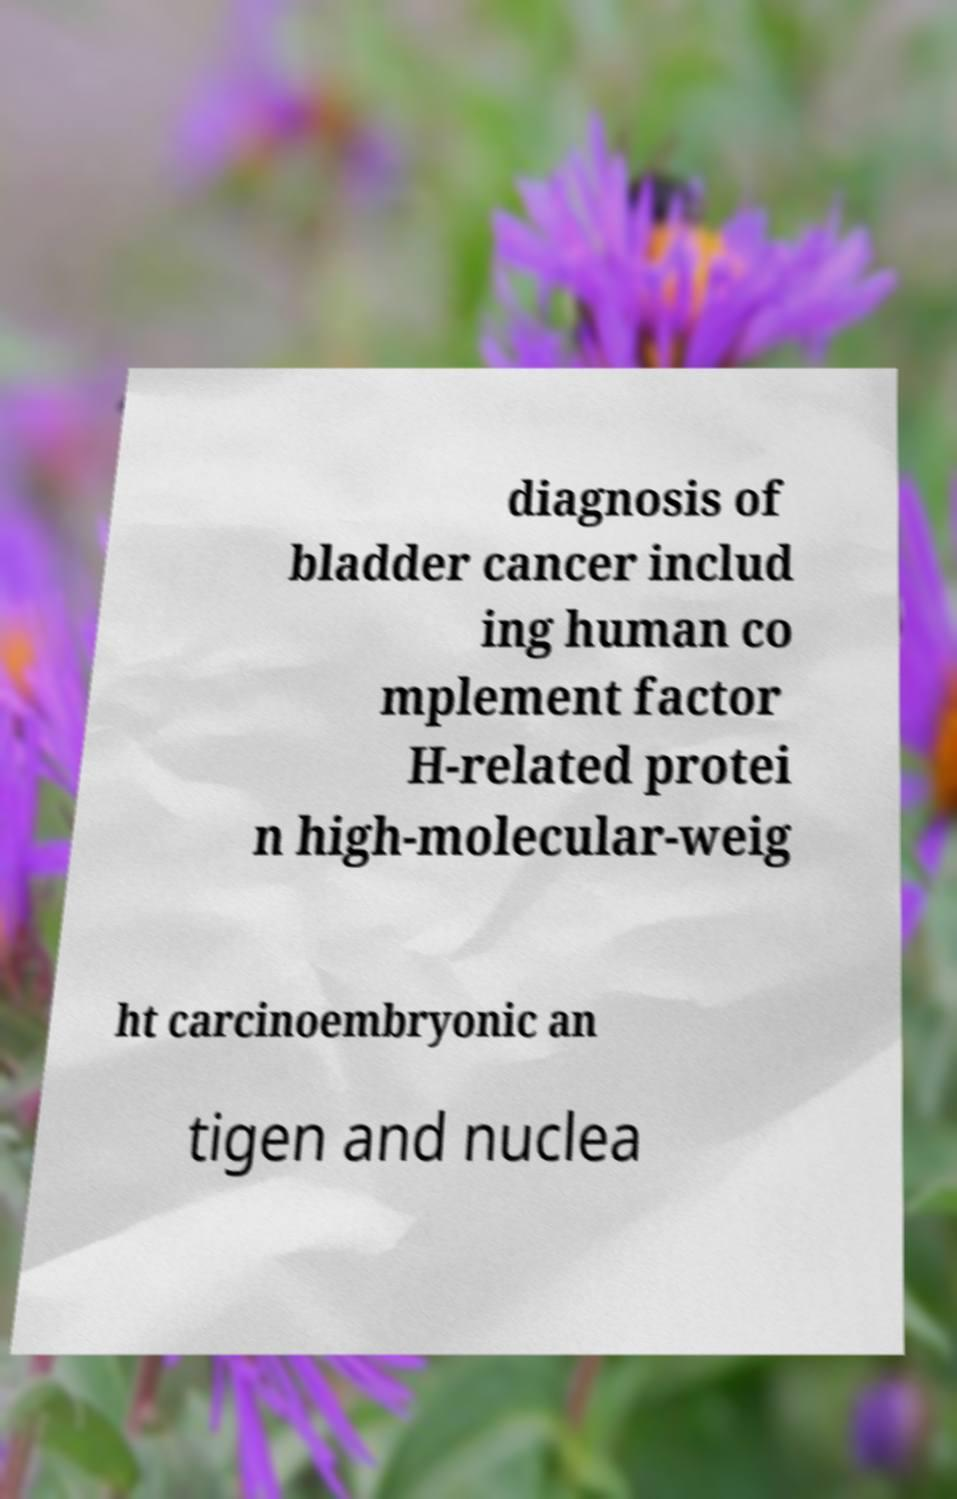There's text embedded in this image that I need extracted. Can you transcribe it verbatim? diagnosis of bladder cancer includ ing human co mplement factor H-related protei n high-molecular-weig ht carcinoembryonic an tigen and nuclea 